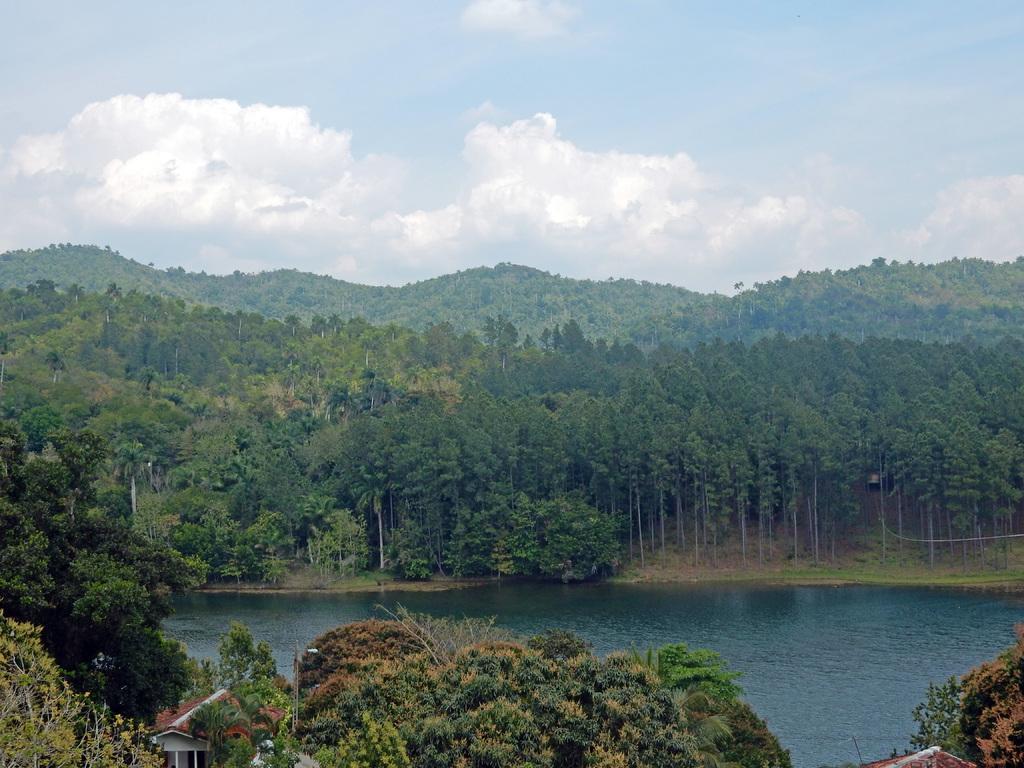How would you summarize this image in a sentence or two? In the foreground of the picture of trees and houses. In the center of the picture there is a water body. In the background there are trees, hills covered with trees and clouds. At the top it is sky. 